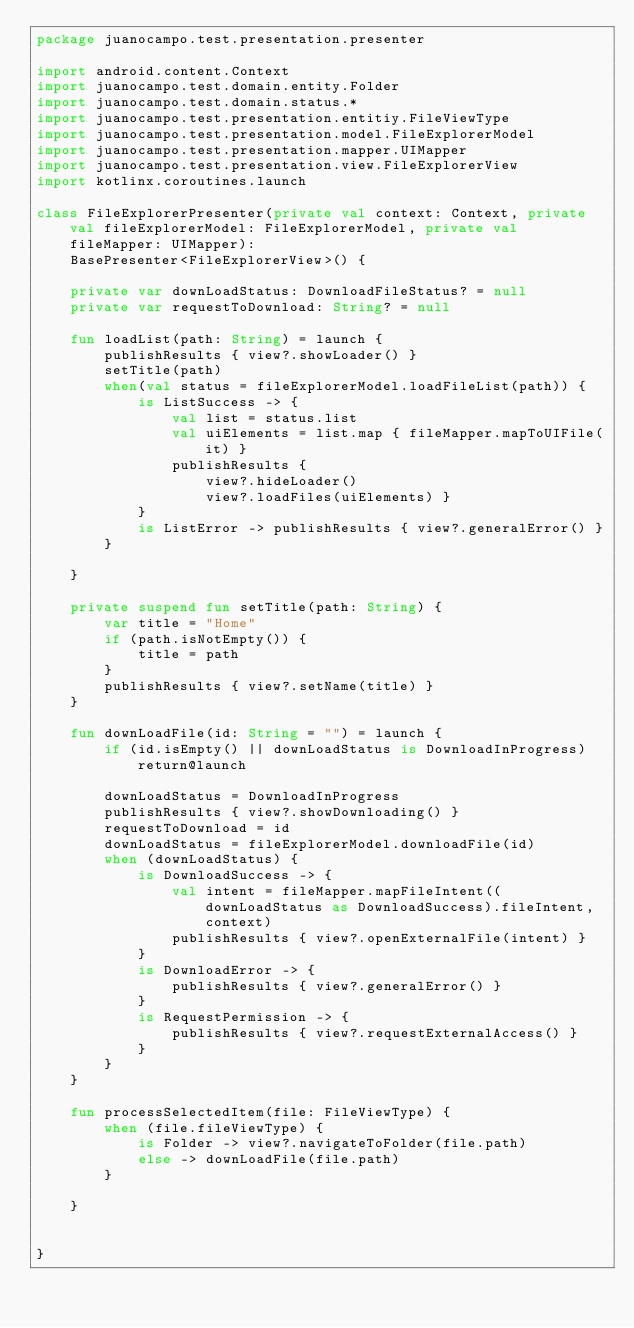Convert code to text. <code><loc_0><loc_0><loc_500><loc_500><_Kotlin_>package juanocampo.test.presentation.presenter

import android.content.Context
import juanocampo.test.domain.entity.Folder
import juanocampo.test.domain.status.*
import juanocampo.test.presentation.entitiy.FileViewType
import juanocampo.test.presentation.model.FileExplorerModel
import juanocampo.test.presentation.mapper.UIMapper
import juanocampo.test.presentation.view.FileExplorerView
import kotlinx.coroutines.launch

class FileExplorerPresenter(private val context: Context, private val fileExplorerModel: FileExplorerModel, private val fileMapper: UIMapper):
    BasePresenter<FileExplorerView>() {

    private var downLoadStatus: DownloadFileStatus? = null
    private var requestToDownload: String? = null

    fun loadList(path: String) = launch {
        publishResults { view?.showLoader() }
        setTitle(path)
        when(val status = fileExplorerModel.loadFileList(path)) {
            is ListSuccess -> {
                val list = status.list
                val uiElements = list.map { fileMapper.mapToUIFile(it) }
                publishResults {
                    view?.hideLoader()
                    view?.loadFiles(uiElements) }
            }
            is ListError -> publishResults { view?.generalError() }
        }

    }

    private suspend fun setTitle(path: String) {
        var title = "Home"
        if (path.isNotEmpty()) {
            title = path
        }
        publishResults { view?.setName(title) }
    }

    fun downLoadFile(id: String = "") = launch {
        if (id.isEmpty() || downLoadStatus is DownloadInProgress) return@launch

        downLoadStatus = DownloadInProgress
        publishResults { view?.showDownloading() }
        requestToDownload = id
        downLoadStatus = fileExplorerModel.downloadFile(id)
        when (downLoadStatus) {
            is DownloadSuccess -> {
                val intent = fileMapper.mapFileIntent((downLoadStatus as DownloadSuccess).fileIntent, context)
                publishResults { view?.openExternalFile(intent) }
            }
            is DownloadError -> {
                publishResults { view?.generalError() }
            }
            is RequestPermission -> {
                publishResults { view?.requestExternalAccess() }
            }
        }
    }

    fun processSelectedItem(file: FileViewType) {
        when (file.fileViewType) {
            is Folder -> view?.navigateToFolder(file.path)
            else -> downLoadFile(file.path)
        }

    }


}</code> 